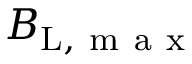<formula> <loc_0><loc_0><loc_500><loc_500>B _ { L , m a x }</formula> 